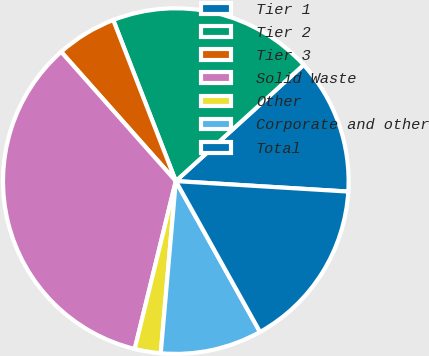Convert chart to OTSL. <chart><loc_0><loc_0><loc_500><loc_500><pie_chart><fcel>Tier 1<fcel>Tier 2<fcel>Tier 3<fcel>Solid Waste<fcel>Other<fcel>Corporate and other<fcel>Total<nl><fcel>12.71%<fcel>19.15%<fcel>5.65%<fcel>34.63%<fcel>2.43%<fcel>9.49%<fcel>15.93%<nl></chart> 